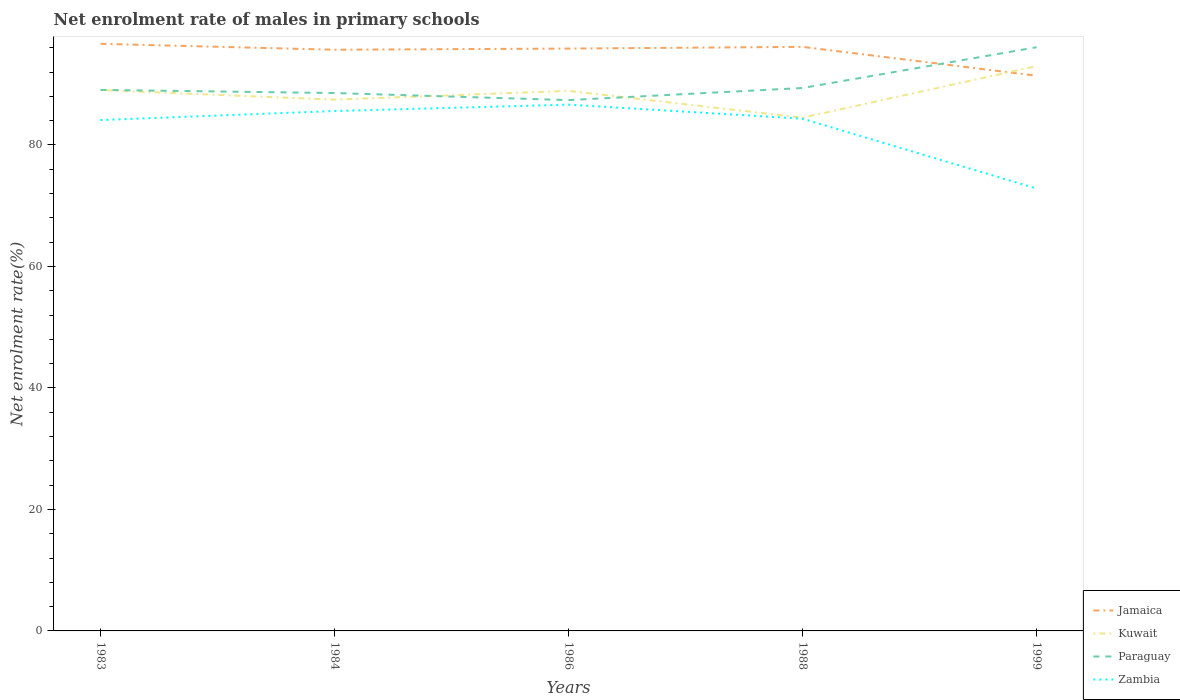Does the line corresponding to Paraguay intersect with the line corresponding to Zambia?
Your response must be concise. No. Across all years, what is the maximum net enrolment rate of males in primary schools in Kuwait?
Ensure brevity in your answer.  84.49. What is the total net enrolment rate of males in primary schools in Paraguay in the graph?
Offer a very short reply. 0.51. What is the difference between the highest and the second highest net enrolment rate of males in primary schools in Jamaica?
Provide a succinct answer. 5.26. Is the net enrolment rate of males in primary schools in Kuwait strictly greater than the net enrolment rate of males in primary schools in Jamaica over the years?
Give a very brief answer. No. How many lines are there?
Provide a short and direct response. 4. How many years are there in the graph?
Give a very brief answer. 5. What is the difference between two consecutive major ticks on the Y-axis?
Provide a succinct answer. 20. How many legend labels are there?
Keep it short and to the point. 4. What is the title of the graph?
Provide a succinct answer. Net enrolment rate of males in primary schools. Does "Swaziland" appear as one of the legend labels in the graph?
Offer a very short reply. No. What is the label or title of the X-axis?
Ensure brevity in your answer.  Years. What is the label or title of the Y-axis?
Your response must be concise. Net enrolment rate(%). What is the Net enrolment rate(%) in Jamaica in 1983?
Provide a succinct answer. 96.65. What is the Net enrolment rate(%) of Kuwait in 1983?
Offer a terse response. 89.03. What is the Net enrolment rate(%) in Paraguay in 1983?
Provide a succinct answer. 89.06. What is the Net enrolment rate(%) of Zambia in 1983?
Provide a short and direct response. 84.09. What is the Net enrolment rate(%) of Jamaica in 1984?
Your response must be concise. 95.67. What is the Net enrolment rate(%) of Kuwait in 1984?
Provide a short and direct response. 87.46. What is the Net enrolment rate(%) in Paraguay in 1984?
Ensure brevity in your answer.  88.54. What is the Net enrolment rate(%) of Zambia in 1984?
Provide a short and direct response. 85.58. What is the Net enrolment rate(%) in Jamaica in 1986?
Offer a very short reply. 95.86. What is the Net enrolment rate(%) in Kuwait in 1986?
Your answer should be very brief. 88.9. What is the Net enrolment rate(%) in Paraguay in 1986?
Provide a succinct answer. 87.38. What is the Net enrolment rate(%) in Zambia in 1986?
Provide a succinct answer. 86.63. What is the Net enrolment rate(%) of Jamaica in 1988?
Offer a terse response. 96.14. What is the Net enrolment rate(%) in Kuwait in 1988?
Offer a very short reply. 84.49. What is the Net enrolment rate(%) of Paraguay in 1988?
Your response must be concise. 89.37. What is the Net enrolment rate(%) in Zambia in 1988?
Provide a short and direct response. 84.31. What is the Net enrolment rate(%) of Jamaica in 1999?
Provide a short and direct response. 91.39. What is the Net enrolment rate(%) in Kuwait in 1999?
Provide a short and direct response. 92.97. What is the Net enrolment rate(%) of Paraguay in 1999?
Offer a terse response. 96.08. What is the Net enrolment rate(%) of Zambia in 1999?
Provide a short and direct response. 72.83. Across all years, what is the maximum Net enrolment rate(%) in Jamaica?
Give a very brief answer. 96.65. Across all years, what is the maximum Net enrolment rate(%) of Kuwait?
Give a very brief answer. 92.97. Across all years, what is the maximum Net enrolment rate(%) of Paraguay?
Your answer should be very brief. 96.08. Across all years, what is the maximum Net enrolment rate(%) in Zambia?
Your answer should be very brief. 86.63. Across all years, what is the minimum Net enrolment rate(%) in Jamaica?
Your response must be concise. 91.39. Across all years, what is the minimum Net enrolment rate(%) of Kuwait?
Provide a succinct answer. 84.49. Across all years, what is the minimum Net enrolment rate(%) in Paraguay?
Offer a terse response. 87.38. Across all years, what is the minimum Net enrolment rate(%) of Zambia?
Your answer should be compact. 72.83. What is the total Net enrolment rate(%) in Jamaica in the graph?
Give a very brief answer. 475.71. What is the total Net enrolment rate(%) of Kuwait in the graph?
Keep it short and to the point. 442.85. What is the total Net enrolment rate(%) in Paraguay in the graph?
Your answer should be compact. 450.44. What is the total Net enrolment rate(%) of Zambia in the graph?
Offer a very short reply. 413.45. What is the difference between the Net enrolment rate(%) of Jamaica in 1983 and that in 1984?
Give a very brief answer. 0.98. What is the difference between the Net enrolment rate(%) in Kuwait in 1983 and that in 1984?
Provide a short and direct response. 1.57. What is the difference between the Net enrolment rate(%) of Paraguay in 1983 and that in 1984?
Make the answer very short. 0.51. What is the difference between the Net enrolment rate(%) in Zambia in 1983 and that in 1984?
Keep it short and to the point. -1.49. What is the difference between the Net enrolment rate(%) in Jamaica in 1983 and that in 1986?
Offer a terse response. 0.78. What is the difference between the Net enrolment rate(%) in Kuwait in 1983 and that in 1986?
Your answer should be compact. 0.13. What is the difference between the Net enrolment rate(%) in Paraguay in 1983 and that in 1986?
Your response must be concise. 1.68. What is the difference between the Net enrolment rate(%) in Zambia in 1983 and that in 1986?
Provide a short and direct response. -2.54. What is the difference between the Net enrolment rate(%) of Jamaica in 1983 and that in 1988?
Your answer should be compact. 0.5. What is the difference between the Net enrolment rate(%) of Kuwait in 1983 and that in 1988?
Offer a terse response. 4.54. What is the difference between the Net enrolment rate(%) in Paraguay in 1983 and that in 1988?
Provide a short and direct response. -0.32. What is the difference between the Net enrolment rate(%) in Zambia in 1983 and that in 1988?
Offer a terse response. -0.22. What is the difference between the Net enrolment rate(%) of Jamaica in 1983 and that in 1999?
Make the answer very short. 5.26. What is the difference between the Net enrolment rate(%) in Kuwait in 1983 and that in 1999?
Ensure brevity in your answer.  -3.94. What is the difference between the Net enrolment rate(%) of Paraguay in 1983 and that in 1999?
Your response must be concise. -7.03. What is the difference between the Net enrolment rate(%) in Zambia in 1983 and that in 1999?
Your answer should be compact. 11.26. What is the difference between the Net enrolment rate(%) of Jamaica in 1984 and that in 1986?
Ensure brevity in your answer.  -0.19. What is the difference between the Net enrolment rate(%) in Kuwait in 1984 and that in 1986?
Your response must be concise. -1.44. What is the difference between the Net enrolment rate(%) of Paraguay in 1984 and that in 1986?
Keep it short and to the point. 1.16. What is the difference between the Net enrolment rate(%) in Zambia in 1984 and that in 1986?
Keep it short and to the point. -1.05. What is the difference between the Net enrolment rate(%) in Jamaica in 1984 and that in 1988?
Provide a succinct answer. -0.47. What is the difference between the Net enrolment rate(%) of Kuwait in 1984 and that in 1988?
Make the answer very short. 2.97. What is the difference between the Net enrolment rate(%) of Paraguay in 1984 and that in 1988?
Keep it short and to the point. -0.83. What is the difference between the Net enrolment rate(%) in Zambia in 1984 and that in 1988?
Your answer should be compact. 1.27. What is the difference between the Net enrolment rate(%) in Jamaica in 1984 and that in 1999?
Offer a very short reply. 4.28. What is the difference between the Net enrolment rate(%) in Kuwait in 1984 and that in 1999?
Provide a short and direct response. -5.52. What is the difference between the Net enrolment rate(%) in Paraguay in 1984 and that in 1999?
Make the answer very short. -7.54. What is the difference between the Net enrolment rate(%) of Zambia in 1984 and that in 1999?
Your answer should be compact. 12.75. What is the difference between the Net enrolment rate(%) in Jamaica in 1986 and that in 1988?
Offer a very short reply. -0.28. What is the difference between the Net enrolment rate(%) in Kuwait in 1986 and that in 1988?
Provide a succinct answer. 4.41. What is the difference between the Net enrolment rate(%) in Paraguay in 1986 and that in 1988?
Offer a very short reply. -2. What is the difference between the Net enrolment rate(%) of Zambia in 1986 and that in 1988?
Offer a terse response. 2.32. What is the difference between the Net enrolment rate(%) of Jamaica in 1986 and that in 1999?
Your response must be concise. 4.48. What is the difference between the Net enrolment rate(%) in Kuwait in 1986 and that in 1999?
Keep it short and to the point. -4.07. What is the difference between the Net enrolment rate(%) of Paraguay in 1986 and that in 1999?
Make the answer very short. -8.71. What is the difference between the Net enrolment rate(%) in Zambia in 1986 and that in 1999?
Offer a terse response. 13.8. What is the difference between the Net enrolment rate(%) of Jamaica in 1988 and that in 1999?
Your answer should be compact. 4.76. What is the difference between the Net enrolment rate(%) in Kuwait in 1988 and that in 1999?
Ensure brevity in your answer.  -8.49. What is the difference between the Net enrolment rate(%) of Paraguay in 1988 and that in 1999?
Your answer should be very brief. -6.71. What is the difference between the Net enrolment rate(%) in Zambia in 1988 and that in 1999?
Your answer should be compact. 11.48. What is the difference between the Net enrolment rate(%) of Jamaica in 1983 and the Net enrolment rate(%) of Kuwait in 1984?
Your answer should be compact. 9.19. What is the difference between the Net enrolment rate(%) in Jamaica in 1983 and the Net enrolment rate(%) in Paraguay in 1984?
Give a very brief answer. 8.1. What is the difference between the Net enrolment rate(%) in Jamaica in 1983 and the Net enrolment rate(%) in Zambia in 1984?
Provide a short and direct response. 11.07. What is the difference between the Net enrolment rate(%) in Kuwait in 1983 and the Net enrolment rate(%) in Paraguay in 1984?
Offer a very short reply. 0.49. What is the difference between the Net enrolment rate(%) in Kuwait in 1983 and the Net enrolment rate(%) in Zambia in 1984?
Offer a very short reply. 3.45. What is the difference between the Net enrolment rate(%) of Paraguay in 1983 and the Net enrolment rate(%) of Zambia in 1984?
Make the answer very short. 3.48. What is the difference between the Net enrolment rate(%) of Jamaica in 1983 and the Net enrolment rate(%) of Kuwait in 1986?
Offer a terse response. 7.75. What is the difference between the Net enrolment rate(%) of Jamaica in 1983 and the Net enrolment rate(%) of Paraguay in 1986?
Offer a very short reply. 9.27. What is the difference between the Net enrolment rate(%) of Jamaica in 1983 and the Net enrolment rate(%) of Zambia in 1986?
Provide a succinct answer. 10.01. What is the difference between the Net enrolment rate(%) of Kuwait in 1983 and the Net enrolment rate(%) of Paraguay in 1986?
Make the answer very short. 1.65. What is the difference between the Net enrolment rate(%) of Kuwait in 1983 and the Net enrolment rate(%) of Zambia in 1986?
Your response must be concise. 2.4. What is the difference between the Net enrolment rate(%) of Paraguay in 1983 and the Net enrolment rate(%) of Zambia in 1986?
Provide a succinct answer. 2.42. What is the difference between the Net enrolment rate(%) in Jamaica in 1983 and the Net enrolment rate(%) in Kuwait in 1988?
Keep it short and to the point. 12.16. What is the difference between the Net enrolment rate(%) of Jamaica in 1983 and the Net enrolment rate(%) of Paraguay in 1988?
Your response must be concise. 7.27. What is the difference between the Net enrolment rate(%) in Jamaica in 1983 and the Net enrolment rate(%) in Zambia in 1988?
Offer a terse response. 12.33. What is the difference between the Net enrolment rate(%) of Kuwait in 1983 and the Net enrolment rate(%) of Paraguay in 1988?
Provide a succinct answer. -0.34. What is the difference between the Net enrolment rate(%) in Kuwait in 1983 and the Net enrolment rate(%) in Zambia in 1988?
Your answer should be compact. 4.71. What is the difference between the Net enrolment rate(%) of Paraguay in 1983 and the Net enrolment rate(%) of Zambia in 1988?
Ensure brevity in your answer.  4.74. What is the difference between the Net enrolment rate(%) of Jamaica in 1983 and the Net enrolment rate(%) of Kuwait in 1999?
Your response must be concise. 3.67. What is the difference between the Net enrolment rate(%) of Jamaica in 1983 and the Net enrolment rate(%) of Paraguay in 1999?
Offer a very short reply. 0.56. What is the difference between the Net enrolment rate(%) of Jamaica in 1983 and the Net enrolment rate(%) of Zambia in 1999?
Your answer should be very brief. 23.81. What is the difference between the Net enrolment rate(%) of Kuwait in 1983 and the Net enrolment rate(%) of Paraguay in 1999?
Keep it short and to the point. -7.05. What is the difference between the Net enrolment rate(%) of Kuwait in 1983 and the Net enrolment rate(%) of Zambia in 1999?
Give a very brief answer. 16.2. What is the difference between the Net enrolment rate(%) in Paraguay in 1983 and the Net enrolment rate(%) in Zambia in 1999?
Make the answer very short. 16.23. What is the difference between the Net enrolment rate(%) in Jamaica in 1984 and the Net enrolment rate(%) in Kuwait in 1986?
Provide a short and direct response. 6.77. What is the difference between the Net enrolment rate(%) of Jamaica in 1984 and the Net enrolment rate(%) of Paraguay in 1986?
Offer a very short reply. 8.29. What is the difference between the Net enrolment rate(%) in Jamaica in 1984 and the Net enrolment rate(%) in Zambia in 1986?
Give a very brief answer. 9.04. What is the difference between the Net enrolment rate(%) of Kuwait in 1984 and the Net enrolment rate(%) of Paraguay in 1986?
Offer a terse response. 0.08. What is the difference between the Net enrolment rate(%) in Kuwait in 1984 and the Net enrolment rate(%) in Zambia in 1986?
Offer a terse response. 0.82. What is the difference between the Net enrolment rate(%) of Paraguay in 1984 and the Net enrolment rate(%) of Zambia in 1986?
Your response must be concise. 1.91. What is the difference between the Net enrolment rate(%) of Jamaica in 1984 and the Net enrolment rate(%) of Kuwait in 1988?
Make the answer very short. 11.18. What is the difference between the Net enrolment rate(%) of Jamaica in 1984 and the Net enrolment rate(%) of Paraguay in 1988?
Offer a terse response. 6.3. What is the difference between the Net enrolment rate(%) in Jamaica in 1984 and the Net enrolment rate(%) in Zambia in 1988?
Your answer should be compact. 11.36. What is the difference between the Net enrolment rate(%) in Kuwait in 1984 and the Net enrolment rate(%) in Paraguay in 1988?
Your answer should be very brief. -1.92. What is the difference between the Net enrolment rate(%) of Kuwait in 1984 and the Net enrolment rate(%) of Zambia in 1988?
Give a very brief answer. 3.14. What is the difference between the Net enrolment rate(%) in Paraguay in 1984 and the Net enrolment rate(%) in Zambia in 1988?
Make the answer very short. 4.23. What is the difference between the Net enrolment rate(%) in Jamaica in 1984 and the Net enrolment rate(%) in Kuwait in 1999?
Keep it short and to the point. 2.7. What is the difference between the Net enrolment rate(%) in Jamaica in 1984 and the Net enrolment rate(%) in Paraguay in 1999?
Offer a very short reply. -0.41. What is the difference between the Net enrolment rate(%) of Jamaica in 1984 and the Net enrolment rate(%) of Zambia in 1999?
Offer a very short reply. 22.84. What is the difference between the Net enrolment rate(%) of Kuwait in 1984 and the Net enrolment rate(%) of Paraguay in 1999?
Your answer should be very brief. -8.63. What is the difference between the Net enrolment rate(%) in Kuwait in 1984 and the Net enrolment rate(%) in Zambia in 1999?
Give a very brief answer. 14.63. What is the difference between the Net enrolment rate(%) in Paraguay in 1984 and the Net enrolment rate(%) in Zambia in 1999?
Ensure brevity in your answer.  15.71. What is the difference between the Net enrolment rate(%) of Jamaica in 1986 and the Net enrolment rate(%) of Kuwait in 1988?
Offer a terse response. 11.38. What is the difference between the Net enrolment rate(%) of Jamaica in 1986 and the Net enrolment rate(%) of Paraguay in 1988?
Offer a very short reply. 6.49. What is the difference between the Net enrolment rate(%) in Jamaica in 1986 and the Net enrolment rate(%) in Zambia in 1988?
Make the answer very short. 11.55. What is the difference between the Net enrolment rate(%) in Kuwait in 1986 and the Net enrolment rate(%) in Paraguay in 1988?
Provide a short and direct response. -0.47. What is the difference between the Net enrolment rate(%) in Kuwait in 1986 and the Net enrolment rate(%) in Zambia in 1988?
Provide a short and direct response. 4.59. What is the difference between the Net enrolment rate(%) in Paraguay in 1986 and the Net enrolment rate(%) in Zambia in 1988?
Offer a terse response. 3.06. What is the difference between the Net enrolment rate(%) of Jamaica in 1986 and the Net enrolment rate(%) of Kuwait in 1999?
Provide a short and direct response. 2.89. What is the difference between the Net enrolment rate(%) of Jamaica in 1986 and the Net enrolment rate(%) of Paraguay in 1999?
Your response must be concise. -0.22. What is the difference between the Net enrolment rate(%) in Jamaica in 1986 and the Net enrolment rate(%) in Zambia in 1999?
Your response must be concise. 23.03. What is the difference between the Net enrolment rate(%) in Kuwait in 1986 and the Net enrolment rate(%) in Paraguay in 1999?
Your response must be concise. -7.18. What is the difference between the Net enrolment rate(%) of Kuwait in 1986 and the Net enrolment rate(%) of Zambia in 1999?
Your response must be concise. 16.07. What is the difference between the Net enrolment rate(%) in Paraguay in 1986 and the Net enrolment rate(%) in Zambia in 1999?
Provide a succinct answer. 14.55. What is the difference between the Net enrolment rate(%) of Jamaica in 1988 and the Net enrolment rate(%) of Kuwait in 1999?
Your answer should be very brief. 3.17. What is the difference between the Net enrolment rate(%) in Jamaica in 1988 and the Net enrolment rate(%) in Paraguay in 1999?
Make the answer very short. 0.06. What is the difference between the Net enrolment rate(%) in Jamaica in 1988 and the Net enrolment rate(%) in Zambia in 1999?
Give a very brief answer. 23.31. What is the difference between the Net enrolment rate(%) of Kuwait in 1988 and the Net enrolment rate(%) of Paraguay in 1999?
Your answer should be very brief. -11.6. What is the difference between the Net enrolment rate(%) of Kuwait in 1988 and the Net enrolment rate(%) of Zambia in 1999?
Offer a terse response. 11.65. What is the difference between the Net enrolment rate(%) of Paraguay in 1988 and the Net enrolment rate(%) of Zambia in 1999?
Give a very brief answer. 16.54. What is the average Net enrolment rate(%) in Jamaica per year?
Ensure brevity in your answer.  95.14. What is the average Net enrolment rate(%) in Kuwait per year?
Offer a very short reply. 88.57. What is the average Net enrolment rate(%) in Paraguay per year?
Offer a terse response. 90.09. What is the average Net enrolment rate(%) of Zambia per year?
Offer a terse response. 82.69. In the year 1983, what is the difference between the Net enrolment rate(%) of Jamaica and Net enrolment rate(%) of Kuwait?
Provide a succinct answer. 7.62. In the year 1983, what is the difference between the Net enrolment rate(%) in Jamaica and Net enrolment rate(%) in Paraguay?
Keep it short and to the point. 7.59. In the year 1983, what is the difference between the Net enrolment rate(%) of Jamaica and Net enrolment rate(%) of Zambia?
Give a very brief answer. 12.55. In the year 1983, what is the difference between the Net enrolment rate(%) of Kuwait and Net enrolment rate(%) of Paraguay?
Your answer should be compact. -0.03. In the year 1983, what is the difference between the Net enrolment rate(%) in Kuwait and Net enrolment rate(%) in Zambia?
Your answer should be compact. 4.94. In the year 1983, what is the difference between the Net enrolment rate(%) in Paraguay and Net enrolment rate(%) in Zambia?
Keep it short and to the point. 4.96. In the year 1984, what is the difference between the Net enrolment rate(%) in Jamaica and Net enrolment rate(%) in Kuwait?
Provide a succinct answer. 8.21. In the year 1984, what is the difference between the Net enrolment rate(%) of Jamaica and Net enrolment rate(%) of Paraguay?
Keep it short and to the point. 7.13. In the year 1984, what is the difference between the Net enrolment rate(%) in Jamaica and Net enrolment rate(%) in Zambia?
Offer a terse response. 10.09. In the year 1984, what is the difference between the Net enrolment rate(%) of Kuwait and Net enrolment rate(%) of Paraguay?
Provide a short and direct response. -1.09. In the year 1984, what is the difference between the Net enrolment rate(%) of Kuwait and Net enrolment rate(%) of Zambia?
Give a very brief answer. 1.88. In the year 1984, what is the difference between the Net enrolment rate(%) in Paraguay and Net enrolment rate(%) in Zambia?
Your answer should be very brief. 2.96. In the year 1986, what is the difference between the Net enrolment rate(%) in Jamaica and Net enrolment rate(%) in Kuwait?
Keep it short and to the point. 6.96. In the year 1986, what is the difference between the Net enrolment rate(%) of Jamaica and Net enrolment rate(%) of Paraguay?
Your response must be concise. 8.48. In the year 1986, what is the difference between the Net enrolment rate(%) of Jamaica and Net enrolment rate(%) of Zambia?
Your response must be concise. 9.23. In the year 1986, what is the difference between the Net enrolment rate(%) in Kuwait and Net enrolment rate(%) in Paraguay?
Your answer should be compact. 1.52. In the year 1986, what is the difference between the Net enrolment rate(%) in Kuwait and Net enrolment rate(%) in Zambia?
Offer a terse response. 2.27. In the year 1986, what is the difference between the Net enrolment rate(%) in Paraguay and Net enrolment rate(%) in Zambia?
Give a very brief answer. 0.74. In the year 1988, what is the difference between the Net enrolment rate(%) in Jamaica and Net enrolment rate(%) in Kuwait?
Your response must be concise. 11.66. In the year 1988, what is the difference between the Net enrolment rate(%) in Jamaica and Net enrolment rate(%) in Paraguay?
Offer a very short reply. 6.77. In the year 1988, what is the difference between the Net enrolment rate(%) in Jamaica and Net enrolment rate(%) in Zambia?
Keep it short and to the point. 11.83. In the year 1988, what is the difference between the Net enrolment rate(%) of Kuwait and Net enrolment rate(%) of Paraguay?
Provide a short and direct response. -4.89. In the year 1988, what is the difference between the Net enrolment rate(%) in Kuwait and Net enrolment rate(%) in Zambia?
Keep it short and to the point. 0.17. In the year 1988, what is the difference between the Net enrolment rate(%) in Paraguay and Net enrolment rate(%) in Zambia?
Your answer should be very brief. 5.06. In the year 1999, what is the difference between the Net enrolment rate(%) of Jamaica and Net enrolment rate(%) of Kuwait?
Provide a succinct answer. -1.59. In the year 1999, what is the difference between the Net enrolment rate(%) in Jamaica and Net enrolment rate(%) in Paraguay?
Provide a succinct answer. -4.7. In the year 1999, what is the difference between the Net enrolment rate(%) of Jamaica and Net enrolment rate(%) of Zambia?
Offer a very short reply. 18.56. In the year 1999, what is the difference between the Net enrolment rate(%) in Kuwait and Net enrolment rate(%) in Paraguay?
Offer a very short reply. -3.11. In the year 1999, what is the difference between the Net enrolment rate(%) of Kuwait and Net enrolment rate(%) of Zambia?
Provide a short and direct response. 20.14. In the year 1999, what is the difference between the Net enrolment rate(%) of Paraguay and Net enrolment rate(%) of Zambia?
Your answer should be very brief. 23.25. What is the ratio of the Net enrolment rate(%) of Jamaica in 1983 to that in 1984?
Offer a very short reply. 1.01. What is the ratio of the Net enrolment rate(%) in Paraguay in 1983 to that in 1984?
Give a very brief answer. 1.01. What is the ratio of the Net enrolment rate(%) in Zambia in 1983 to that in 1984?
Provide a succinct answer. 0.98. What is the ratio of the Net enrolment rate(%) in Jamaica in 1983 to that in 1986?
Keep it short and to the point. 1.01. What is the ratio of the Net enrolment rate(%) of Paraguay in 1983 to that in 1986?
Offer a very short reply. 1.02. What is the ratio of the Net enrolment rate(%) in Zambia in 1983 to that in 1986?
Your answer should be compact. 0.97. What is the ratio of the Net enrolment rate(%) of Jamaica in 1983 to that in 1988?
Make the answer very short. 1.01. What is the ratio of the Net enrolment rate(%) of Kuwait in 1983 to that in 1988?
Ensure brevity in your answer.  1.05. What is the ratio of the Net enrolment rate(%) in Paraguay in 1983 to that in 1988?
Your answer should be compact. 1. What is the ratio of the Net enrolment rate(%) in Zambia in 1983 to that in 1988?
Your response must be concise. 1. What is the ratio of the Net enrolment rate(%) of Jamaica in 1983 to that in 1999?
Keep it short and to the point. 1.06. What is the ratio of the Net enrolment rate(%) in Kuwait in 1983 to that in 1999?
Your answer should be compact. 0.96. What is the ratio of the Net enrolment rate(%) of Paraguay in 1983 to that in 1999?
Provide a succinct answer. 0.93. What is the ratio of the Net enrolment rate(%) of Zambia in 1983 to that in 1999?
Provide a short and direct response. 1.15. What is the ratio of the Net enrolment rate(%) of Kuwait in 1984 to that in 1986?
Your response must be concise. 0.98. What is the ratio of the Net enrolment rate(%) in Paraguay in 1984 to that in 1986?
Your answer should be compact. 1.01. What is the ratio of the Net enrolment rate(%) of Kuwait in 1984 to that in 1988?
Offer a terse response. 1.04. What is the ratio of the Net enrolment rate(%) of Zambia in 1984 to that in 1988?
Your response must be concise. 1.01. What is the ratio of the Net enrolment rate(%) in Jamaica in 1984 to that in 1999?
Ensure brevity in your answer.  1.05. What is the ratio of the Net enrolment rate(%) in Kuwait in 1984 to that in 1999?
Keep it short and to the point. 0.94. What is the ratio of the Net enrolment rate(%) of Paraguay in 1984 to that in 1999?
Make the answer very short. 0.92. What is the ratio of the Net enrolment rate(%) in Zambia in 1984 to that in 1999?
Offer a very short reply. 1.18. What is the ratio of the Net enrolment rate(%) in Kuwait in 1986 to that in 1988?
Provide a succinct answer. 1.05. What is the ratio of the Net enrolment rate(%) of Paraguay in 1986 to that in 1988?
Keep it short and to the point. 0.98. What is the ratio of the Net enrolment rate(%) in Zambia in 1986 to that in 1988?
Offer a very short reply. 1.03. What is the ratio of the Net enrolment rate(%) in Jamaica in 1986 to that in 1999?
Provide a succinct answer. 1.05. What is the ratio of the Net enrolment rate(%) in Kuwait in 1986 to that in 1999?
Provide a succinct answer. 0.96. What is the ratio of the Net enrolment rate(%) in Paraguay in 1986 to that in 1999?
Your answer should be very brief. 0.91. What is the ratio of the Net enrolment rate(%) in Zambia in 1986 to that in 1999?
Provide a succinct answer. 1.19. What is the ratio of the Net enrolment rate(%) of Jamaica in 1988 to that in 1999?
Your answer should be compact. 1.05. What is the ratio of the Net enrolment rate(%) of Kuwait in 1988 to that in 1999?
Your response must be concise. 0.91. What is the ratio of the Net enrolment rate(%) in Paraguay in 1988 to that in 1999?
Your response must be concise. 0.93. What is the ratio of the Net enrolment rate(%) in Zambia in 1988 to that in 1999?
Provide a succinct answer. 1.16. What is the difference between the highest and the second highest Net enrolment rate(%) of Jamaica?
Your answer should be compact. 0.5. What is the difference between the highest and the second highest Net enrolment rate(%) in Kuwait?
Your answer should be very brief. 3.94. What is the difference between the highest and the second highest Net enrolment rate(%) in Paraguay?
Offer a very short reply. 6.71. What is the difference between the highest and the second highest Net enrolment rate(%) of Zambia?
Give a very brief answer. 1.05. What is the difference between the highest and the lowest Net enrolment rate(%) of Jamaica?
Your response must be concise. 5.26. What is the difference between the highest and the lowest Net enrolment rate(%) in Kuwait?
Your answer should be very brief. 8.49. What is the difference between the highest and the lowest Net enrolment rate(%) in Paraguay?
Give a very brief answer. 8.71. What is the difference between the highest and the lowest Net enrolment rate(%) in Zambia?
Keep it short and to the point. 13.8. 